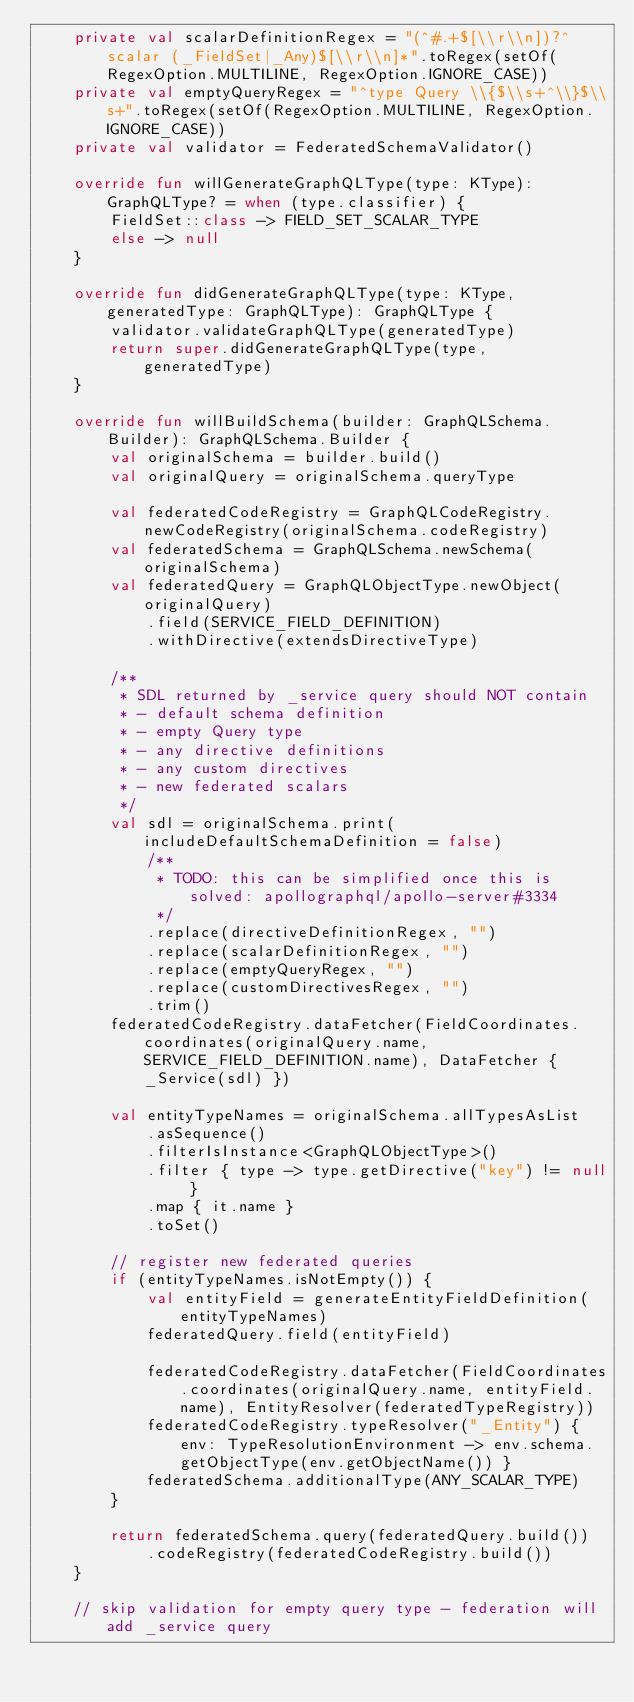Convert code to text. <code><loc_0><loc_0><loc_500><loc_500><_Kotlin_>    private val scalarDefinitionRegex = "(^#.+$[\\r\\n])?^scalar (_FieldSet|_Any)$[\\r\\n]*".toRegex(setOf(RegexOption.MULTILINE, RegexOption.IGNORE_CASE))
    private val emptyQueryRegex = "^type Query \\{$\\s+^\\}$\\s+".toRegex(setOf(RegexOption.MULTILINE, RegexOption.IGNORE_CASE))
    private val validator = FederatedSchemaValidator()

    override fun willGenerateGraphQLType(type: KType): GraphQLType? = when (type.classifier) {
        FieldSet::class -> FIELD_SET_SCALAR_TYPE
        else -> null
    }

    override fun didGenerateGraphQLType(type: KType, generatedType: GraphQLType): GraphQLType {
        validator.validateGraphQLType(generatedType)
        return super.didGenerateGraphQLType(type, generatedType)
    }

    override fun willBuildSchema(builder: GraphQLSchema.Builder): GraphQLSchema.Builder {
        val originalSchema = builder.build()
        val originalQuery = originalSchema.queryType

        val federatedCodeRegistry = GraphQLCodeRegistry.newCodeRegistry(originalSchema.codeRegistry)
        val federatedSchema = GraphQLSchema.newSchema(originalSchema)
        val federatedQuery = GraphQLObjectType.newObject(originalQuery)
            .field(SERVICE_FIELD_DEFINITION)
            .withDirective(extendsDirectiveType)

        /**
         * SDL returned by _service query should NOT contain
         * - default schema definition
         * - empty Query type
         * - any directive definitions
         * - any custom directives
         * - new federated scalars
         */
        val sdl = originalSchema.print(includeDefaultSchemaDefinition = false)
            /**
             * TODO: this can be simplified once this is solved: apollographql/apollo-server#3334
             */
            .replace(directiveDefinitionRegex, "")
            .replace(scalarDefinitionRegex, "")
            .replace(emptyQueryRegex, "")
            .replace(customDirectivesRegex, "")
            .trim()
        federatedCodeRegistry.dataFetcher(FieldCoordinates.coordinates(originalQuery.name, SERVICE_FIELD_DEFINITION.name), DataFetcher { _Service(sdl) })

        val entityTypeNames = originalSchema.allTypesAsList
            .asSequence()
            .filterIsInstance<GraphQLObjectType>()
            .filter { type -> type.getDirective("key") != null }
            .map { it.name }
            .toSet()

        // register new federated queries
        if (entityTypeNames.isNotEmpty()) {
            val entityField = generateEntityFieldDefinition(entityTypeNames)
            federatedQuery.field(entityField)

            federatedCodeRegistry.dataFetcher(FieldCoordinates.coordinates(originalQuery.name, entityField.name), EntityResolver(federatedTypeRegistry))
            federatedCodeRegistry.typeResolver("_Entity") { env: TypeResolutionEnvironment -> env.schema.getObjectType(env.getObjectName()) }
            federatedSchema.additionalType(ANY_SCALAR_TYPE)
        }

        return federatedSchema.query(federatedQuery.build())
            .codeRegistry(federatedCodeRegistry.build())
    }

    // skip validation for empty query type - federation will add _service query</code> 